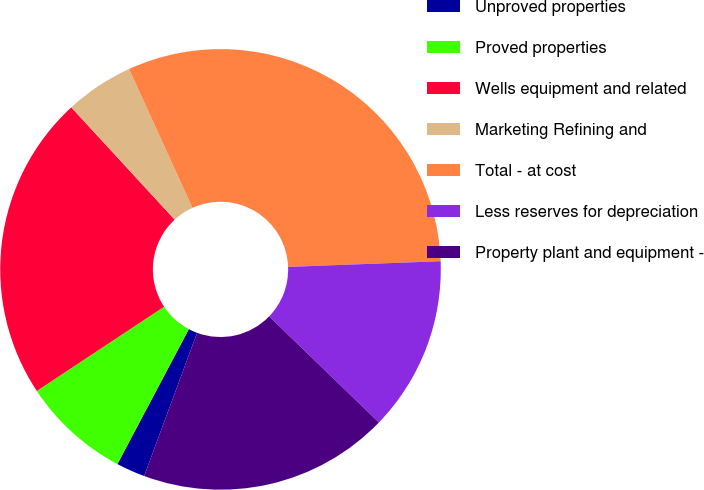Convert chart. <chart><loc_0><loc_0><loc_500><loc_500><pie_chart><fcel>Unproved properties<fcel>Proved properties<fcel>Wells equipment and related<fcel>Marketing Refining and<fcel>Total - at cost<fcel>Less reserves for depreciation<fcel>Property plant and equipment -<nl><fcel>2.12%<fcel>7.94%<fcel>22.46%<fcel>5.03%<fcel>31.22%<fcel>12.82%<fcel>18.4%<nl></chart> 